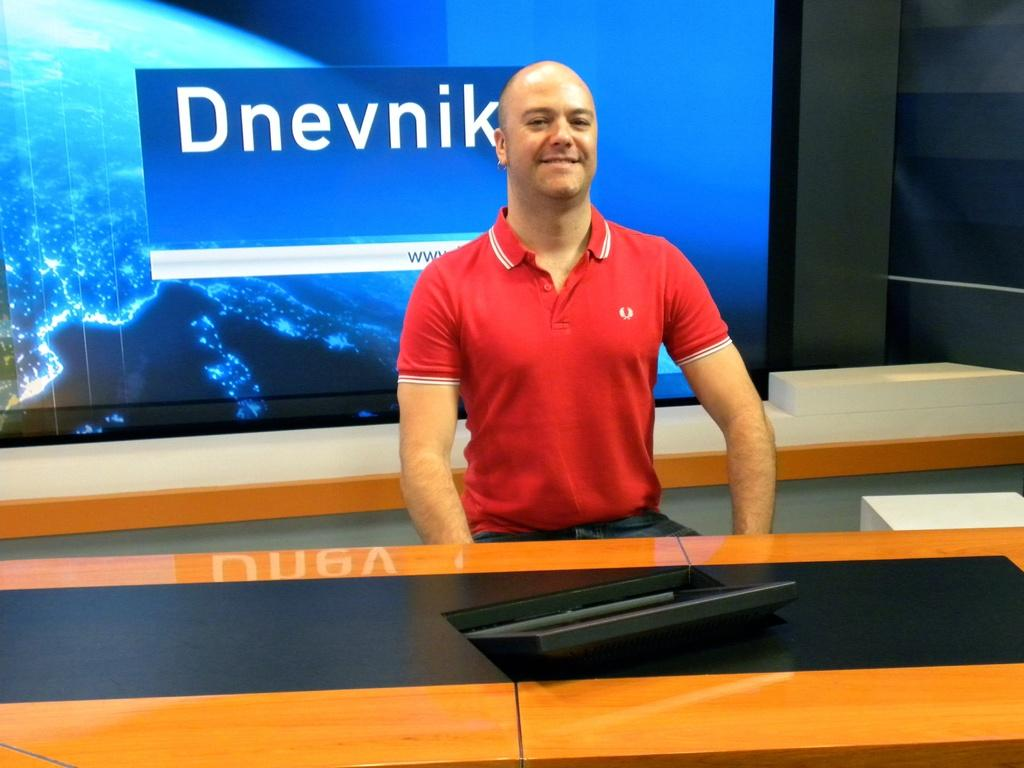<image>
Give a short and clear explanation of the subsequent image. A man in a red polo with a screen behind him reading Dnevnik. 